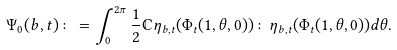Convert formula to latex. <formula><loc_0><loc_0><loc_500><loc_500>\Psi _ { 0 } ( b , t ) \colon = \int _ { 0 } ^ { 2 \pi } \frac { 1 } { 2 } \mathbb { C } \eta _ { b , t } ( \Phi _ { t } ( 1 , \theta , 0 ) ) \colon \eta _ { b , t } ( \Phi _ { t } ( 1 , \theta , 0 ) ) d \theta .</formula> 